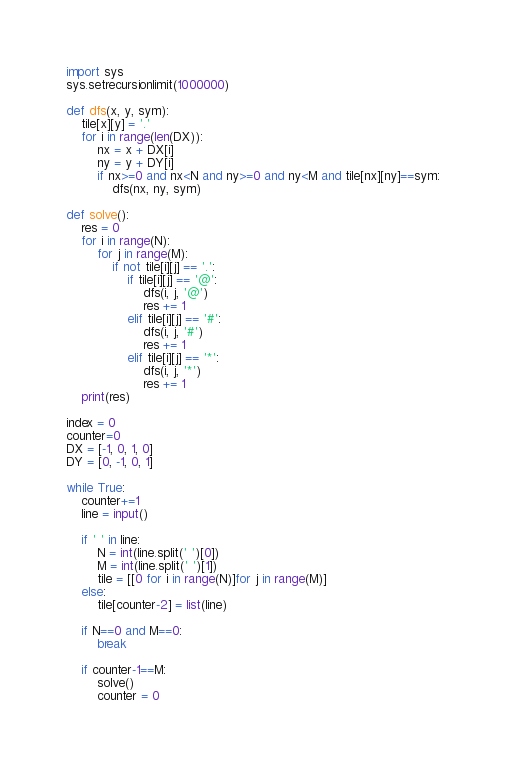<code> <loc_0><loc_0><loc_500><loc_500><_Python_>import sys
sys.setrecursionlimit(1000000)

def dfs(x, y, sym):
	tile[x][y] = '.'
	for i in range(len(DX)):
		nx = x + DX[i]
		ny = y + DY[i]
		if nx>=0 and nx<N and ny>=0 and ny<M and tile[nx][ny]==sym:
			dfs(nx, ny, sym)

def solve():
	res = 0
	for i in range(N):
		for j in range(M):
			if not tile[i][j] == '.':
				if tile[i][j] == '@':
					dfs(i, j, '@')
					res += 1
				elif tile[i][j] == '#':
					dfs(i, j, '#')
					res += 1
				elif tile[i][j] == '*':
					dfs(i, j, '*')
					res += 1
	print(res)

index = 0	
counter=0 
DX = [-1, 0, 1, 0]
DY = [0, -1, 0, 1]

while True:
	counter+=1
	line = input()
	
	if ' ' in line:
		N = int(line.split(' ')[0])
		M = int(line.split(' ')[1])
		tile = [[0 for i in range(N)]for j in range(M)]
	else:
		tile[counter-2] = list(line)

	if N==0 and M==0:
		break

	if counter-1==M:
		solve()
		counter = 0</code> 